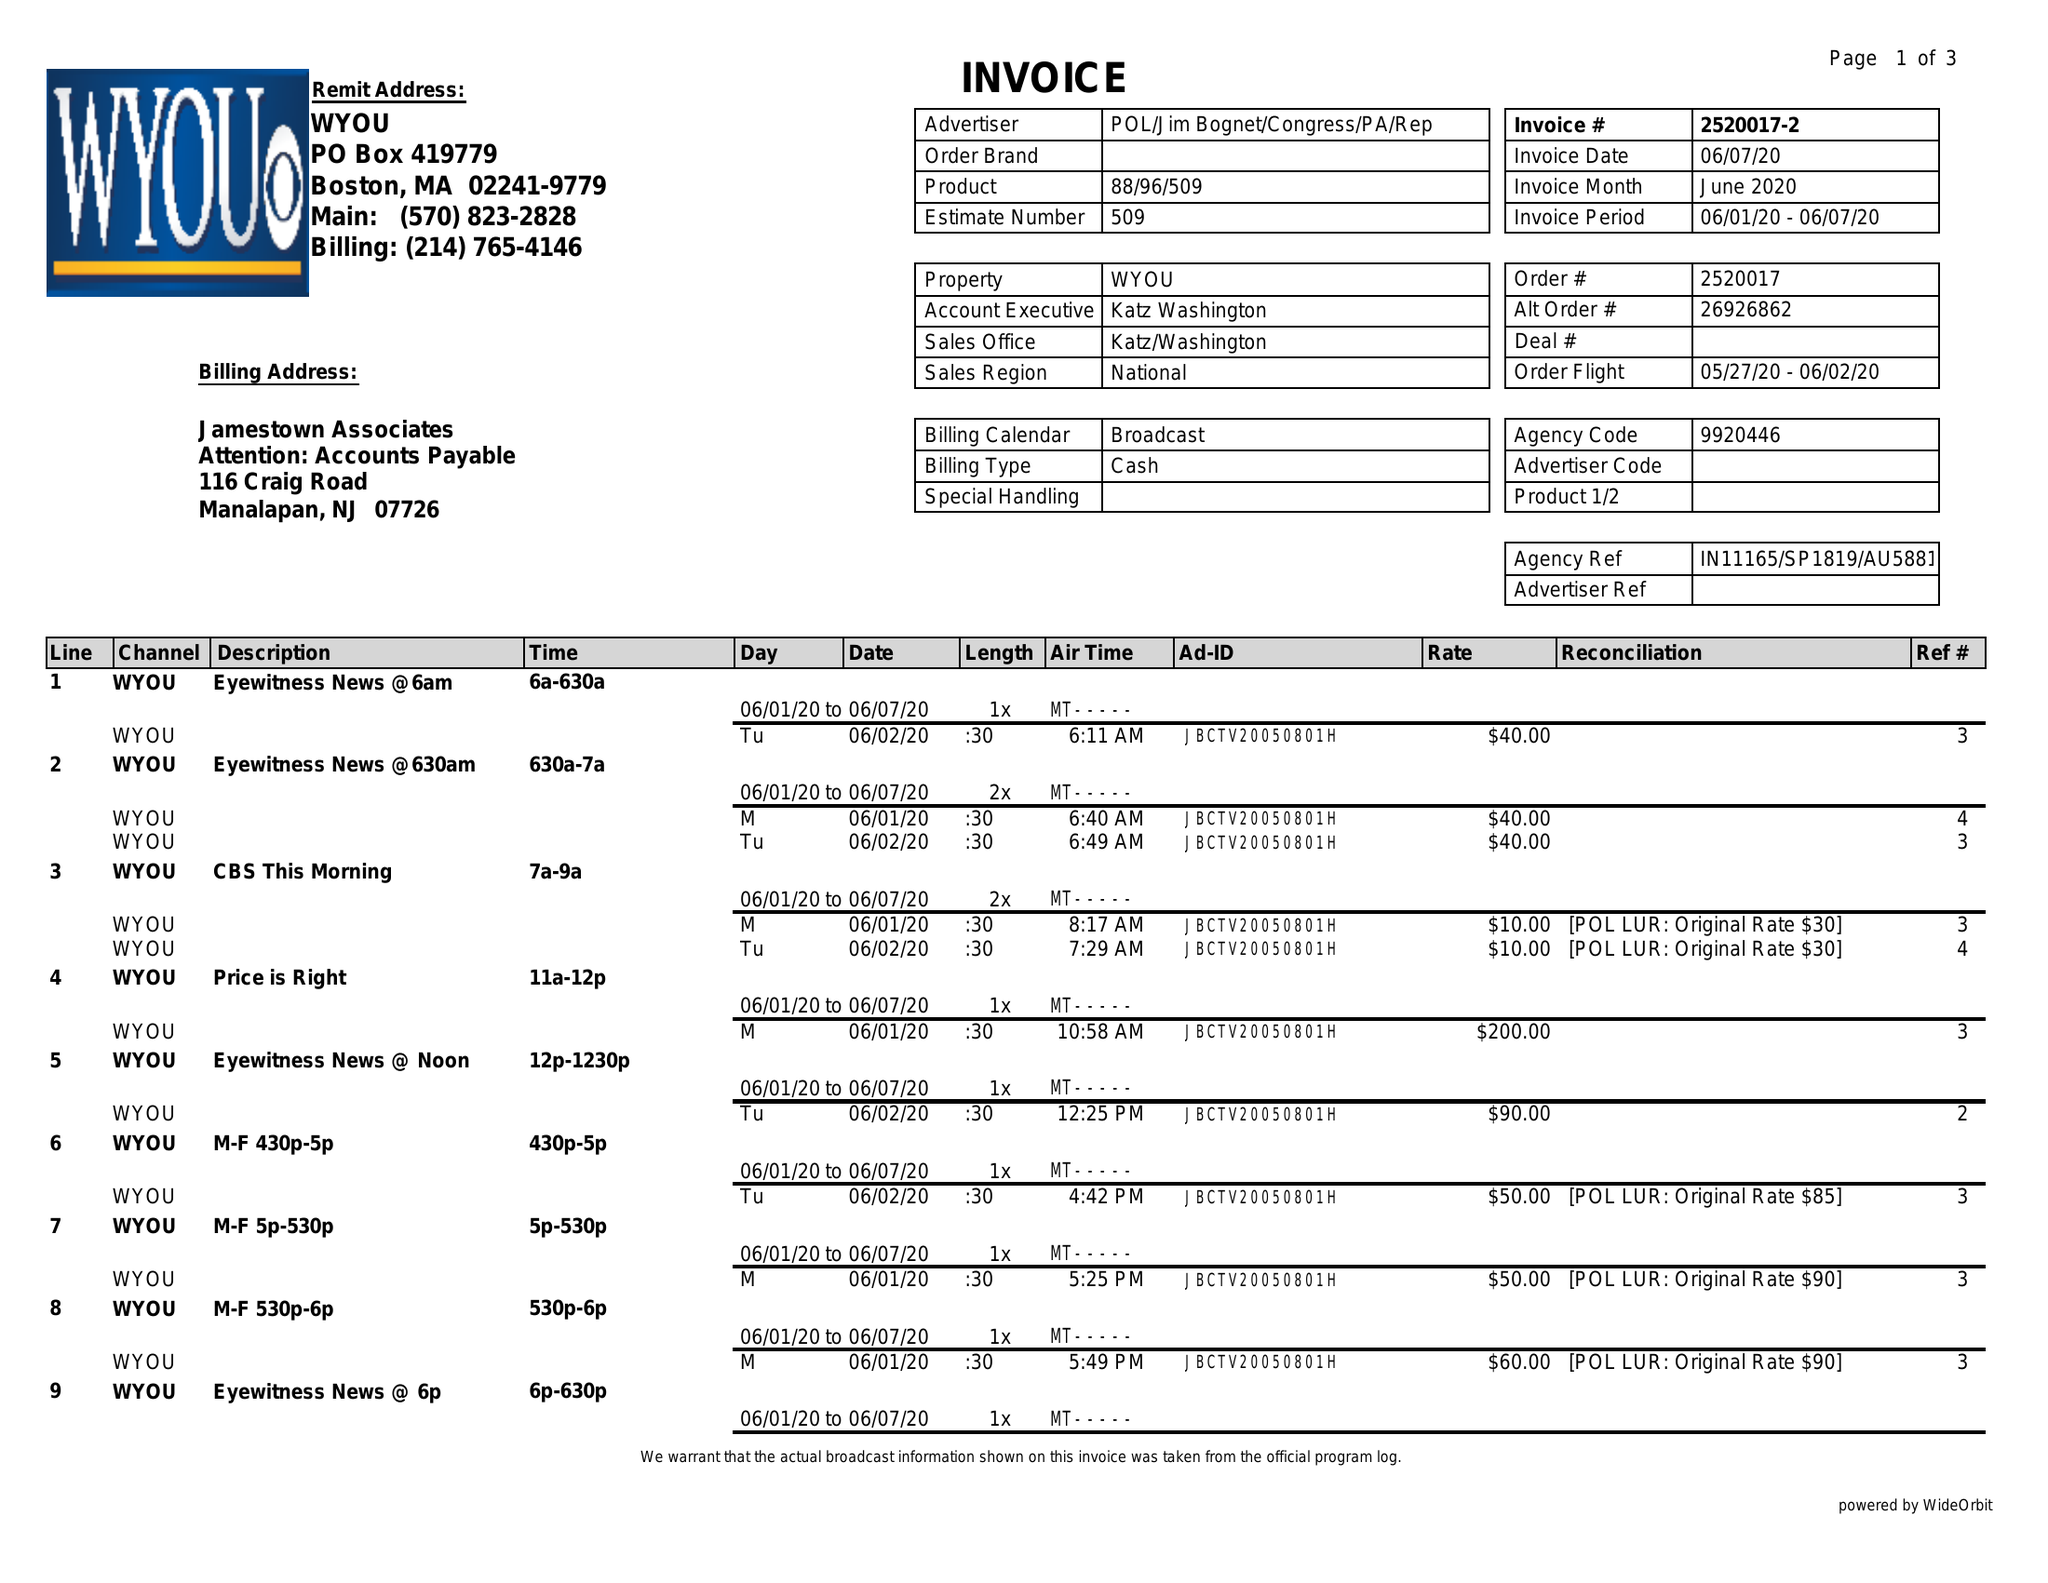What is the value for the contract_num?
Answer the question using a single word or phrase. 2520017 